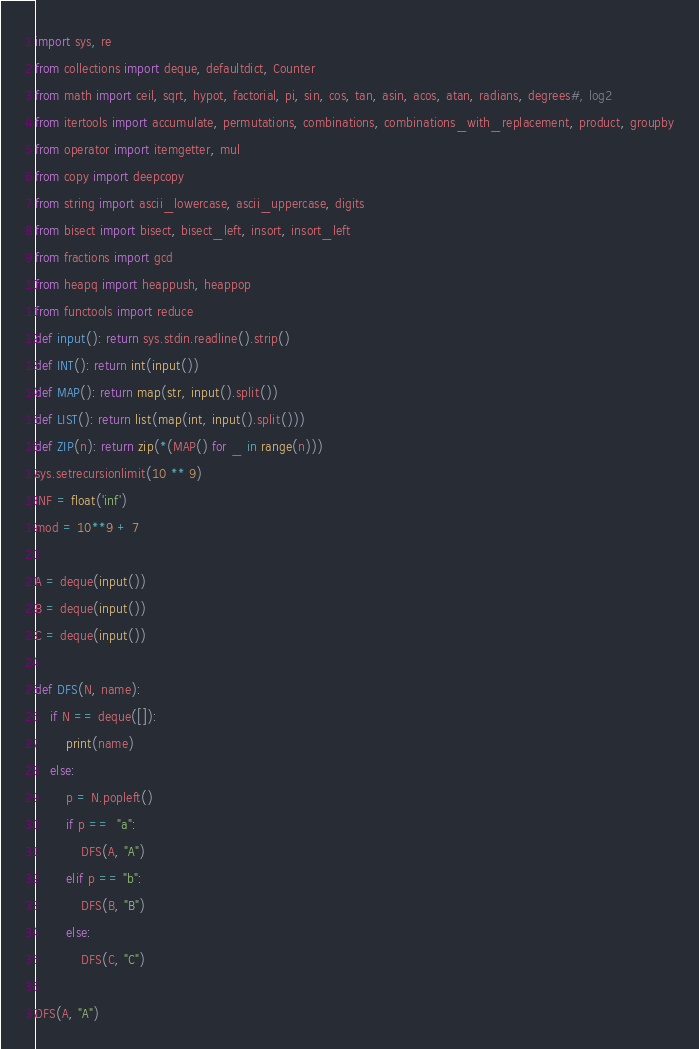<code> <loc_0><loc_0><loc_500><loc_500><_Python_>import sys, re
from collections import deque, defaultdict, Counter
from math import ceil, sqrt, hypot, factorial, pi, sin, cos, tan, asin, acos, atan, radians, degrees#, log2
from itertools import accumulate, permutations, combinations, combinations_with_replacement, product, groupby
from operator import itemgetter, mul
from copy import deepcopy
from string import ascii_lowercase, ascii_uppercase, digits
from bisect import bisect, bisect_left, insort, insort_left
from fractions import gcd
from heapq import heappush, heappop
from functools import reduce
def input(): return sys.stdin.readline().strip()
def INT(): return int(input())
def MAP(): return map(str, input().split())
def LIST(): return list(map(int, input().split()))
def ZIP(n): return zip(*(MAP() for _ in range(n)))
sys.setrecursionlimit(10 ** 9)
INF = float('inf')
mod = 10**9 + 7

A = deque(input())
B = deque(input())
C = deque(input())

def DFS(N, name):
	if N == deque([]):
		print(name)
	else:
		p = N.popleft()
		if p ==  "a":
			DFS(A, "A")
		elif p == "b":
			DFS(B, "B")
		else:
			DFS(C, "C")

DFS(A, "A")</code> 